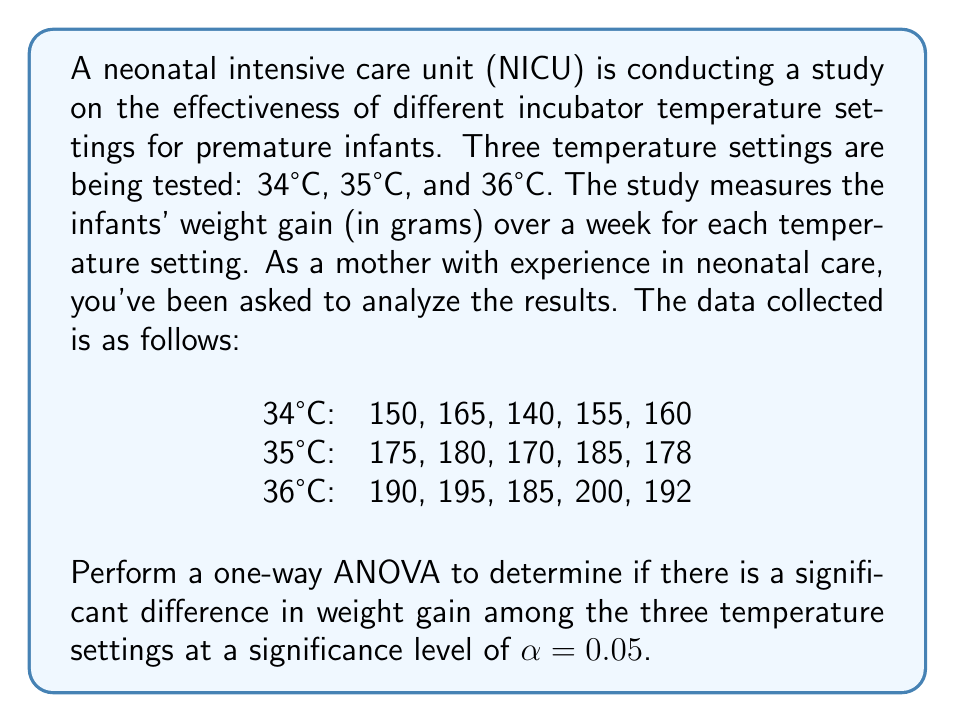What is the answer to this math problem? To perform a one-way ANOVA, we'll follow these steps:

1. Calculate the sum of squares between groups (SSB), sum of squares within groups (SSW), and total sum of squares (SST).
2. Calculate the degrees of freedom for between groups (dfB), within groups (dfW), and total (dfT).
3. Calculate the mean square between groups (MSB) and mean square within groups (MSW).
4. Calculate the F-statistic.
5. Compare the F-statistic to the critical F-value.

Step 1: Calculate sums of squares

First, let's calculate the grand mean:
$$\bar{X} = \frac{150 + 165 + ... + 200 + 192}{15} = 174.67$$

Now, we can calculate SSB, SSW, and SST:

SSB = $\sum_{i=1}^{k} n_i(\bar{X_i} - \bar{X})^2$
    = $5(154 - 174.67)^2 + 5(177.6 - 174.67)^2 + 5(192.4 - 174.67)^2$
    = $2130.13 + 43.23 + 1570.13 = 3743.49$

SSW = $\sum_{i=1}^{k} \sum_{j=1}^{n_i} (X_{ij} - \bar{X_i})^2$
    = $[(150-154)^2 + ... + (160-154)^2] + [(175-177.6)^2 + ... + (178-177.6)^2] + [(190-192.4)^2 + ... + (192-192.4)^2]$
    = $325 + 137 + 137 = 599$

SST = SSB + SSW = $3743.49 + 599 = 4342.49$

Step 2: Calculate degrees of freedom

dfB = $k - 1 = 3 - 1 = 2$
dfW = $N - k = 15 - 3 = 12$
dfT = $N - 1 = 15 - 1 = 14$

Step 3: Calculate mean squares

MSB = $\frac{SSB}{dfB} = \frac{3743.49}{2} = 1871.745$
MSW = $\frac{SSW}{dfW} = \frac{599}{12} = 49.917$

Step 4: Calculate F-statistic

$F = \frac{MSB}{MSW} = \frac{1871.745}{49.917} = 37.497$

Step 5: Compare F-statistic to critical F-value

The critical F-value for $\alpha = 0.05$, dfB = 2, and dfW = 12 is approximately 3.89.

Since our calculated F-statistic (37.497) is greater than the critical F-value (3.89), we reject the null hypothesis.
Answer: The one-way ANOVA results show a significant difference in weight gain among the three incubator temperature settings (F(2,12) = 37.497, p < 0.05). This suggests that the temperature setting has a significant effect on the weight gain of premature infants in the NICU. 